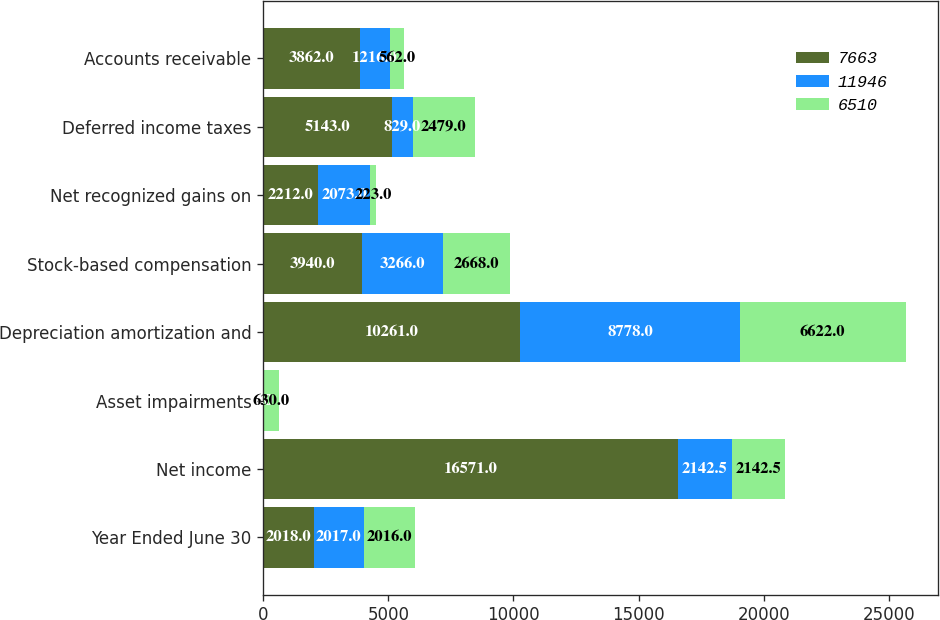Convert chart to OTSL. <chart><loc_0><loc_0><loc_500><loc_500><stacked_bar_chart><ecel><fcel>Year Ended June 30<fcel>Net income<fcel>Asset impairments<fcel>Depreciation amortization and<fcel>Stock-based compensation<fcel>Net recognized gains on<fcel>Deferred income taxes<fcel>Accounts receivable<nl><fcel>7663<fcel>2018<fcel>16571<fcel>0<fcel>10261<fcel>3940<fcel>2212<fcel>5143<fcel>3862<nl><fcel>11946<fcel>2017<fcel>2142.5<fcel>0<fcel>8778<fcel>3266<fcel>2073<fcel>829<fcel>1216<nl><fcel>6510<fcel>2016<fcel>2142.5<fcel>630<fcel>6622<fcel>2668<fcel>223<fcel>2479<fcel>562<nl></chart> 